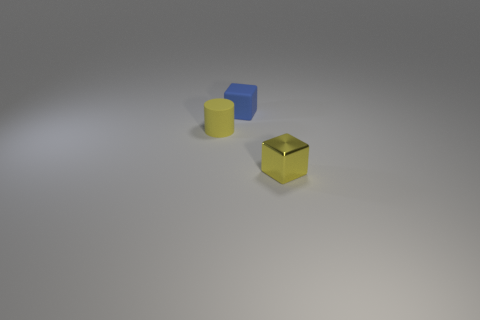Add 1 cyan blocks. How many objects exist? 4 Subtract all cylinders. How many objects are left? 2 Subtract 0 red balls. How many objects are left? 3 Subtract all yellow cylinders. Subtract all tiny blue shiny cylinders. How many objects are left? 2 Add 1 rubber cylinders. How many rubber cylinders are left? 2 Add 1 large blue matte things. How many large blue matte things exist? 1 